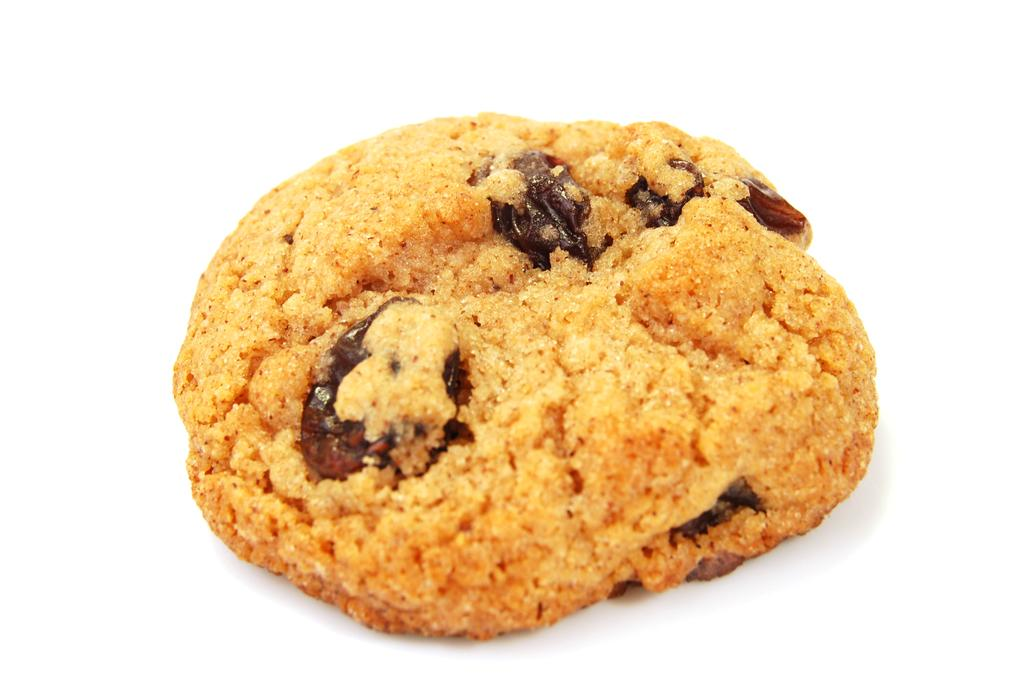What is the main subject of the image? There is a cookie in the image. What color is the background of the image? The background of the image is white. Where can the honey be found in the image? There is no honey present in the image. What type of cake is shown in the image? There is no cake present in the image. 